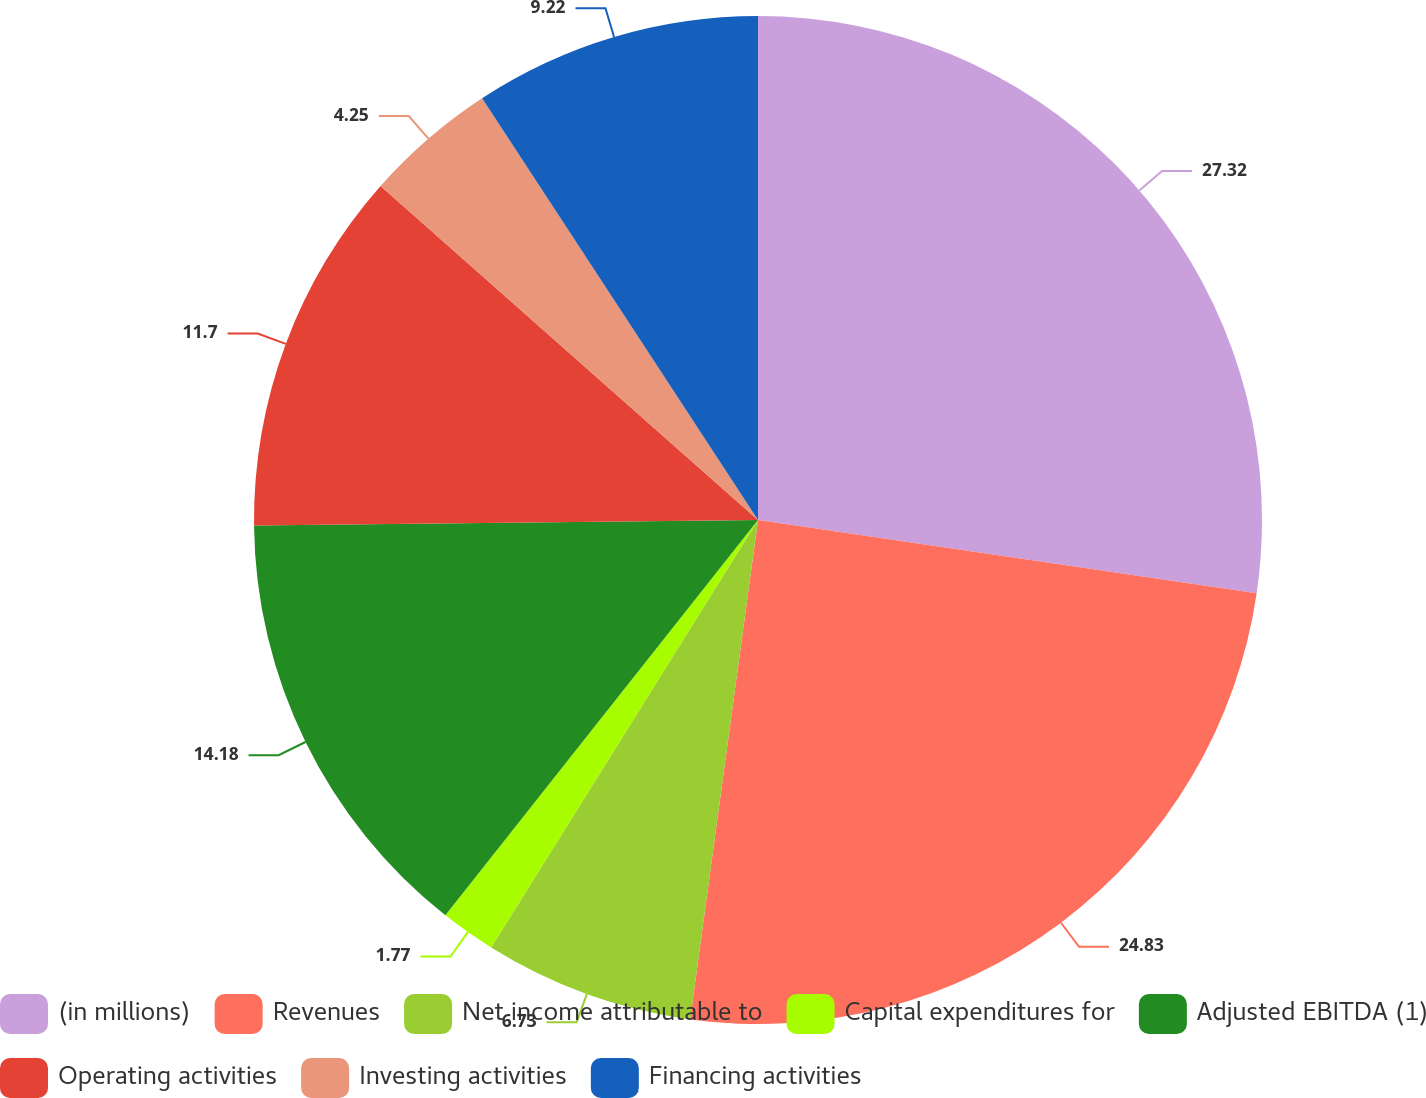Convert chart. <chart><loc_0><loc_0><loc_500><loc_500><pie_chart><fcel>(in millions)<fcel>Revenues<fcel>Net income attributable to<fcel>Capital expenditures for<fcel>Adjusted EBITDA (1)<fcel>Operating activities<fcel>Investing activities<fcel>Financing activities<nl><fcel>27.32%<fcel>24.83%<fcel>6.73%<fcel>1.77%<fcel>14.18%<fcel>11.7%<fcel>4.25%<fcel>9.22%<nl></chart> 